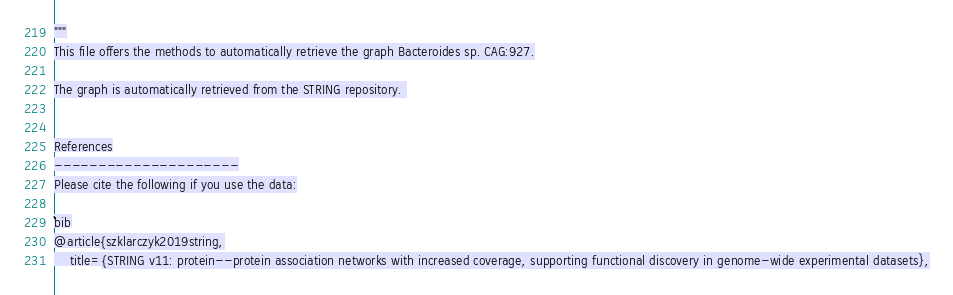Convert code to text. <code><loc_0><loc_0><loc_500><loc_500><_Python_>"""
This file offers the methods to automatically retrieve the graph Bacteroides sp. CAG:927.

The graph is automatically retrieved from the STRING repository. 


References
---------------------
Please cite the following if you use the data:

```bib
@article{szklarczyk2019string,
    title={STRING v11: protein--protein association networks with increased coverage, supporting functional discovery in genome-wide experimental datasets},</code> 